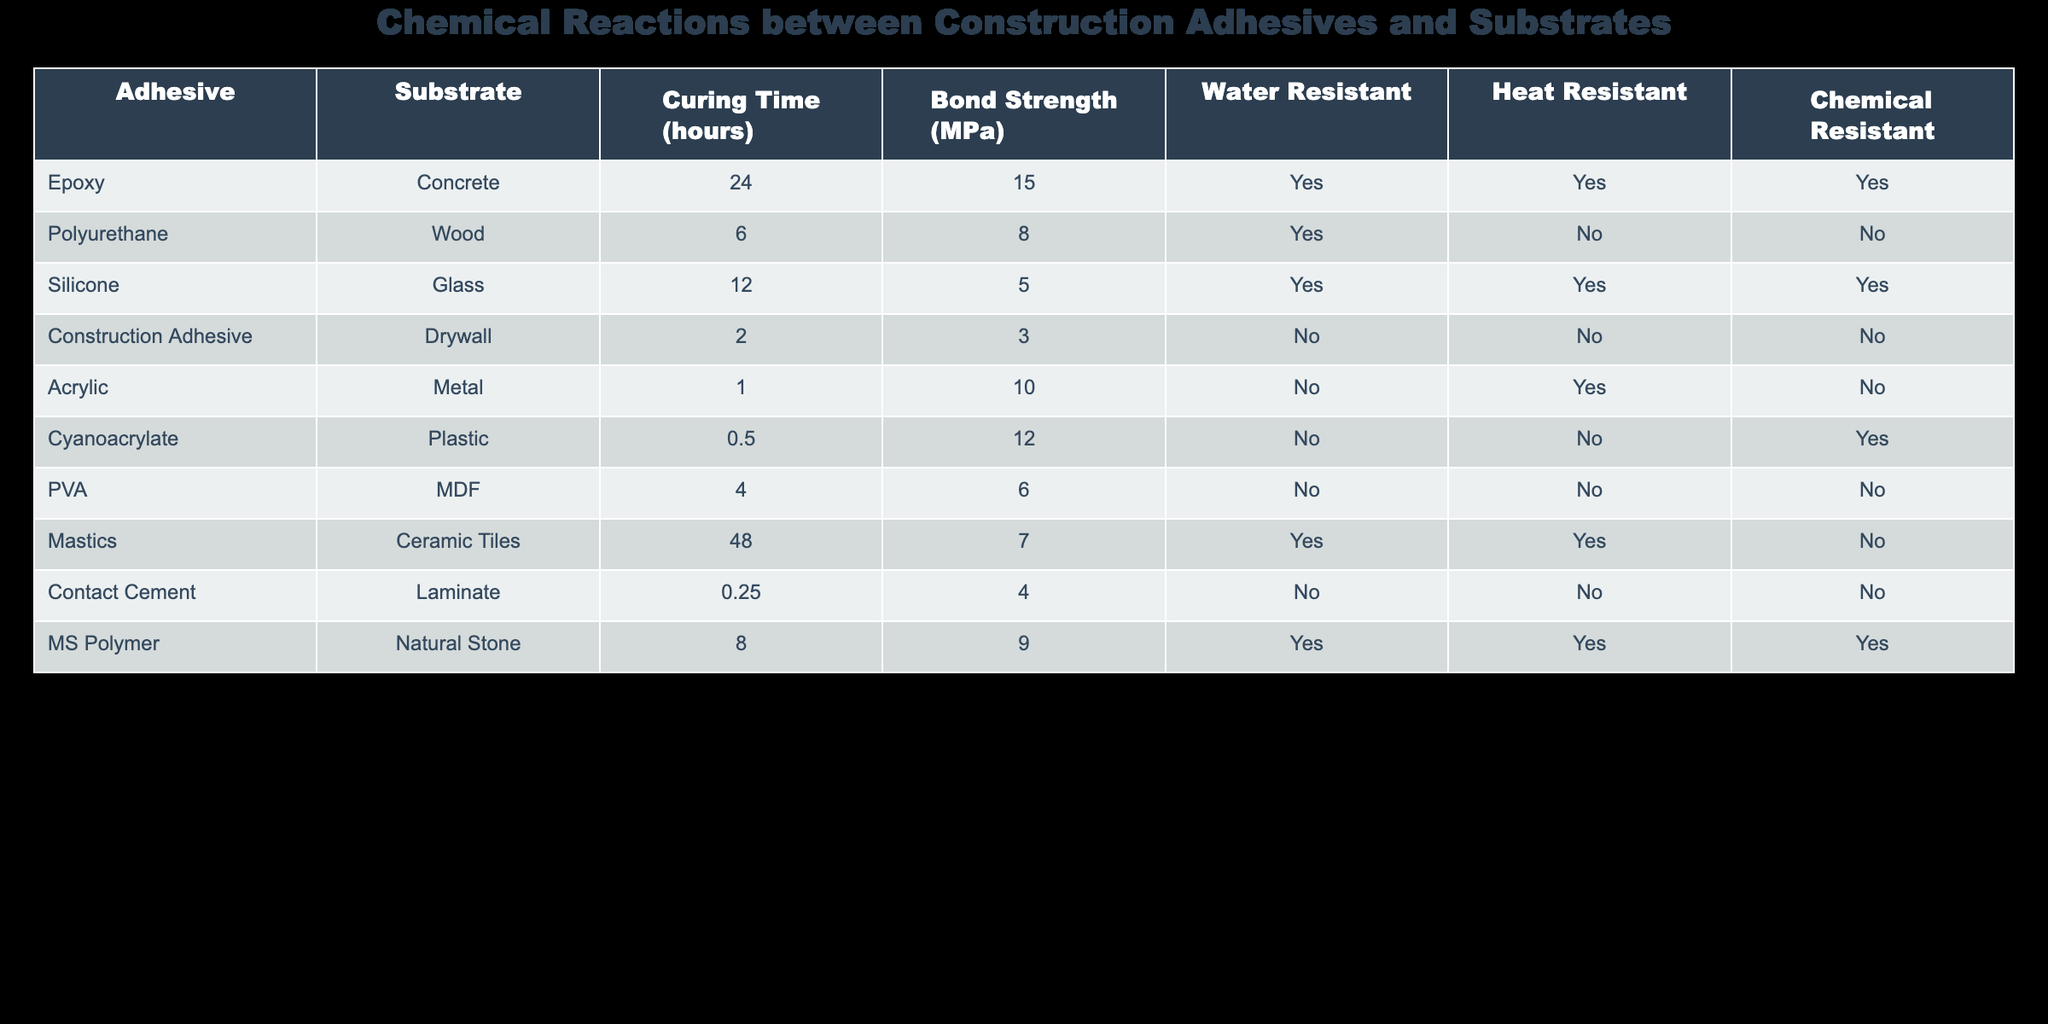What is the bond strength of the Epoxy with Concrete? The bond strength is specifically listed in the row for Epoxy and Concrete in the table. It states that the bond strength is 15 MPa.
Answer: 15 MPa How long does it take for Polyurethane adhesives to cure on Wood? The curing time for Polyurethane on Wood is found in the relevant row of the table, which states it takes 6 hours.
Answer: 6 hours Which adhesive has the highest bond strength? To determine which adhesive has the highest bond strength, I need to look through the bond strength values across all adhesives. The Epoxy with Concrete has the highest value of 15 MPa.
Answer: Epoxy with Concrete Is the Construction Adhesive water-resistant? Looking at the attributes of the Construction Adhesive in the table, the value under water-resistant is listed as "No."
Answer: No What is the average bond strength of the adhesives categorized as water-resistant? To find the average bond strength of water-resistant adhesives, I will first list the adhesives that are water-resistant: Epoxy (15 MPa), Silicone (5 MPa), Mastics (7 MPa), and MS Polymer (9 MPa). The sum of these values is 15 + 5 + 7 + 9 = 36 MPa. There are 4 values, so the average is 36/4 = 9 MPa.
Answer: 9 MPa Are any adhesives both heat resistant and chemical resistant? By checking the relevant columns for heat resistance and chemical resistance, I see that Epoxy and MS Polymer both have "Yes" in both columns. Thus, both meet these criteria.
Answer: Yes What is the bond strength of the adhesive that has the shortest curing time? The shortest curing time is 0.25 hours for Contact Cement according to the table. The bond strength listed for Contact Cement is 4 MPa.
Answer: 4 MPa Which adhesive can be used on natural stone and is also heat resistant? Referring to the table, the only adhesive listed for natural stone that is also heat resistant is MS Polymer.
Answer: MS Polymer What proportion of adhesives listed are not water resistant? From the table, I can count 4 adhesives that are not water resistant: Polyurethane, Construction Adhesive, Acrylic, and PVA. There are a total of 9 adhesives, so the proportion is 4 out of 9. This can be expressed as 4/9 or approximately 0.44 when calculated.
Answer: 4/9 